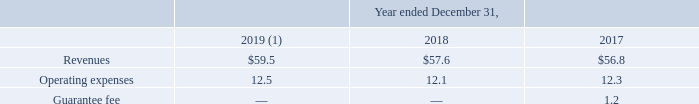FNF
We are party to certain agreements with FNF, including agreements that were entered into when we were related parties. As a result of the Distribution, FNF no longer has an ownership interest in us, but was still considered a related party until December 1, 2019 due to the combination of certain shared board members, members of senior management and various agreements. As of December 1, 2019, the Chairman of our Board of Directors no longer serves as one of our executive officers, and FNF is no longer considered a related party.
We have various agreements with FNF to provide software, data and analytics services, as well as corporate shared services and information technology. We are also a party to certain other agreements under which we incur other expenses or receive revenues from FNF.
A detail of the revenues and expenses, net from FNF is as follows (in millions):
(1) Transactions with FNF are summarized through November 30, 2019, the date after which FNF is no longer considered a related party.
We paid to FNF a guarantee fee of 1.0% of the outstanding principal of the Senior Notes (as defined in Note 12 — Long Term Debt) in exchange for the guarantee by FNF of the Senior Notes. For the year ended December 31, 2017, the guarantee fee was included in Interest expense, net on the Consolidated Statements of Earnings and Comprehensive Earnings. On April 26, 2017, the Senior Notes were redeemed, and we are no longer required to pay a guarantee fee.
What does the company's agreements with FNF entail the provision of? Software, data and analytics services, as well as corporate shared services and information technology. What was the revenue in 2019?
Answer scale should be: million. 59.5. What were the operating expenses in 2017?
Answer scale should be: million. 12.3. Which years did Revenues exceed $55 million? (2019:59.5),(2018:57.6),(2017:56.8)
Answer: 2019, 2018, 2017. What was the change in operating expenses between 2017 and 2018?
Answer scale should be: million. 12.1-12.3
Answer: -0.2. What was the percentage change in operating expenses between 2018 and 2019?
Answer scale should be: percent. (12.5-12.1)/12.1
Answer: 3.31. 